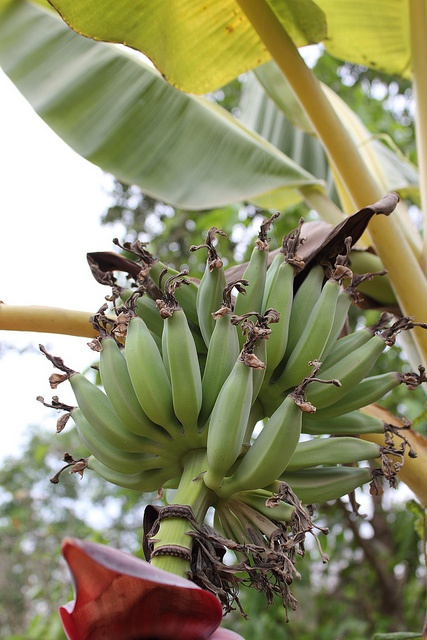Describe the objects in this image and their specific colors. I can see a banana in olive, darkgreen, and gray tones in this image. 